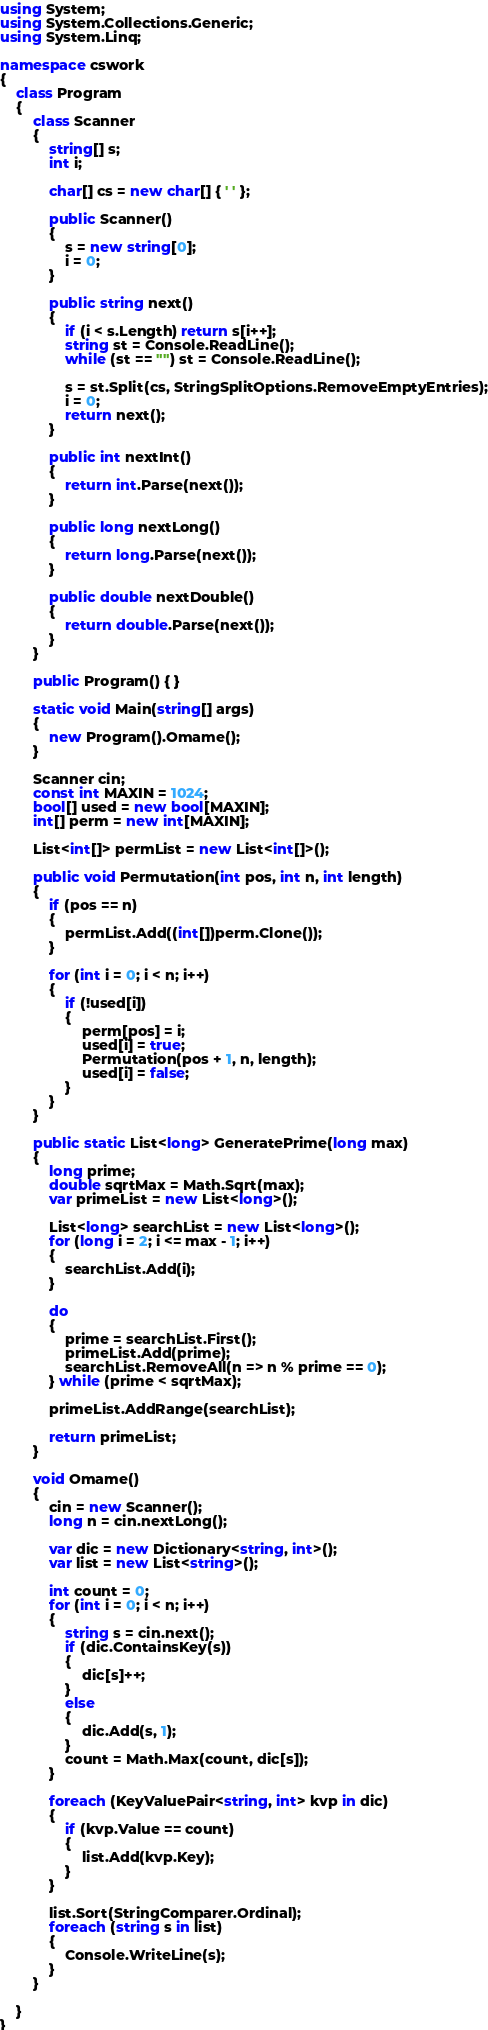<code> <loc_0><loc_0><loc_500><loc_500><_C#_>using System;
using System.Collections.Generic;
using System.Linq;

namespace cswork
{
    class Program
    {
        class Scanner
        {
            string[] s;
            int i;

            char[] cs = new char[] { ' ' };

            public Scanner()
            {
                s = new string[0];
                i = 0;
            }

            public string next()
            {
                if (i < s.Length) return s[i++];
                string st = Console.ReadLine();
                while (st == "") st = Console.ReadLine();

                s = st.Split(cs, StringSplitOptions.RemoveEmptyEntries);
                i = 0;
                return next();
            }

            public int nextInt()
            {
                return int.Parse(next());
            }

            public long nextLong()
            {
                return long.Parse(next());
            }

            public double nextDouble()
            {
                return double.Parse(next());
            }
        }

        public Program() { }

        static void Main(string[] args)
        {
            new Program().Omame();
        }

        Scanner cin;
        const int MAXIN = 1024;
        bool[] used = new bool[MAXIN];
        int[] perm = new int[MAXIN];

        List<int[]> permList = new List<int[]>();

        public void Permutation(int pos, int n, int length)
        {
            if (pos == n)
            {
                permList.Add((int[])perm.Clone());
            }

            for (int i = 0; i < n; i++)
            {
                if (!used[i])
                {
                    perm[pos] = i;
                    used[i] = true;
                    Permutation(pos + 1, n, length);
                    used[i] = false;
                }
            }
        }

        public static List<long> GeneratePrime(long max)
        {
            long prime;
            double sqrtMax = Math.Sqrt(max);
            var primeList = new List<long>();

            List<long> searchList = new List<long>();
            for (long i = 2; i <= max - 1; i++)
            {
                searchList.Add(i);
            }

            do
            {
                prime = searchList.First();
                primeList.Add(prime);
                searchList.RemoveAll(n => n % prime == 0);
            } while (prime < sqrtMax);

            primeList.AddRange(searchList);

            return primeList;
        }

        void Omame()
        {
            cin = new Scanner();
            long n = cin.nextLong();

            var dic = new Dictionary<string, int>();
            var list = new List<string>();

            int count = 0;
            for (int i = 0; i < n; i++)
            {
                string s = cin.next();
                if (dic.ContainsKey(s))
                {
                    dic[s]++;
                }
                else
                {
                    dic.Add(s, 1);
                }
                count = Math.Max(count, dic[s]);
            }

            foreach (KeyValuePair<string, int> kvp in dic)
            {
                if (kvp.Value == count)
                {
                    list.Add(kvp.Key);
                }
            }

            list.Sort(StringComparer.Ordinal);
            foreach (string s in list)
            {
                Console.WriteLine(s);
            }
        }

    }
}
</code> 